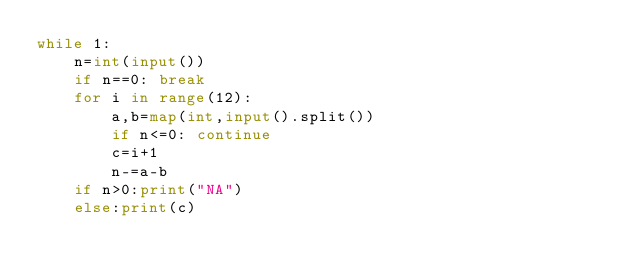<code> <loc_0><loc_0><loc_500><loc_500><_Python_>while 1:
    n=int(input())
    if n==0: break
    for i in range(12):
        a,b=map(int,input().split())
        if n<=0: continue
        c=i+1
        n-=a-b
    if n>0:print("NA")
    else:print(c)</code> 